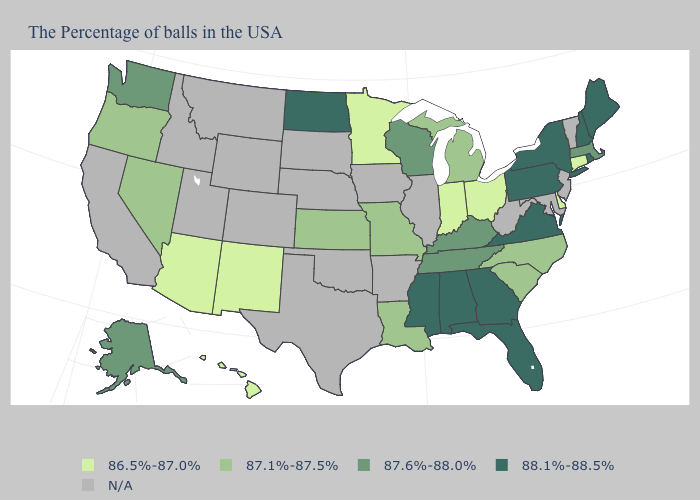Does New York have the highest value in the Northeast?
Write a very short answer. Yes. What is the value of Nevada?
Quick response, please. 87.1%-87.5%. What is the value of Michigan?
Give a very brief answer. 87.1%-87.5%. What is the value of Maine?
Give a very brief answer. 88.1%-88.5%. What is the value of Ohio?
Quick response, please. 86.5%-87.0%. Does Mississippi have the highest value in the South?
Be succinct. Yes. What is the value of Arizona?
Give a very brief answer. 86.5%-87.0%. Which states have the lowest value in the USA?
Give a very brief answer. Connecticut, Delaware, Ohio, Indiana, Minnesota, New Mexico, Arizona, Hawaii. What is the lowest value in states that border Iowa?
Be succinct. 86.5%-87.0%. Name the states that have a value in the range N/A?
Concise answer only. Vermont, New Jersey, Maryland, West Virginia, Illinois, Arkansas, Iowa, Nebraska, Oklahoma, Texas, South Dakota, Wyoming, Colorado, Utah, Montana, Idaho, California. Name the states that have a value in the range 87.6%-88.0%?
Be succinct. Massachusetts, Kentucky, Tennessee, Wisconsin, Washington, Alaska. Name the states that have a value in the range 87.1%-87.5%?
Concise answer only. North Carolina, South Carolina, Michigan, Louisiana, Missouri, Kansas, Nevada, Oregon. What is the value of Mississippi?
Be succinct. 88.1%-88.5%. What is the lowest value in the Northeast?
Concise answer only. 86.5%-87.0%. 